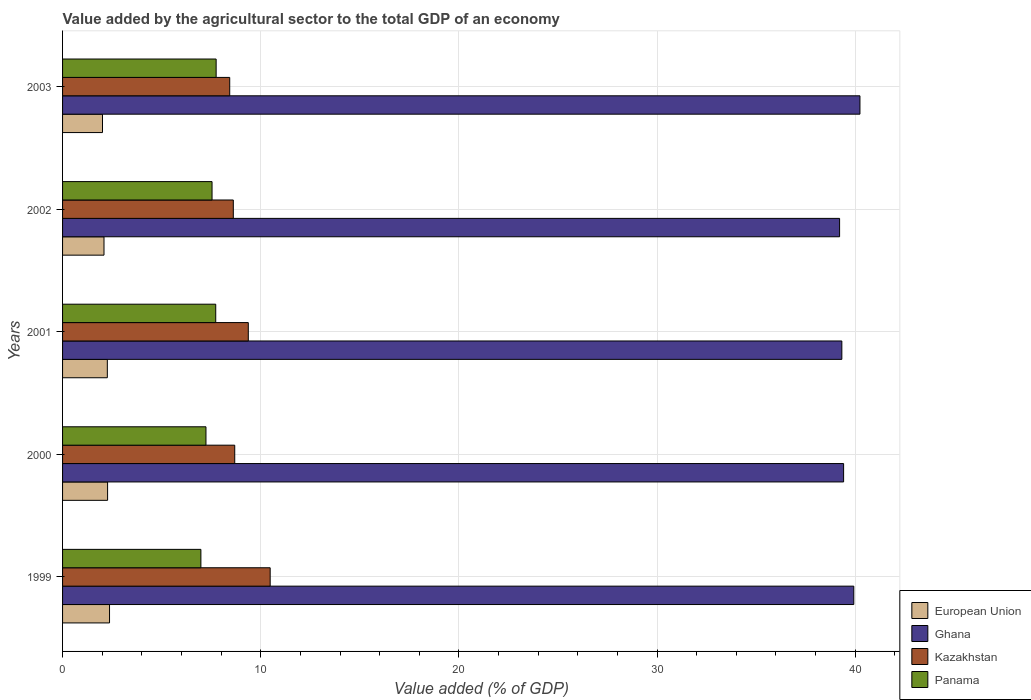How many groups of bars are there?
Ensure brevity in your answer.  5. Are the number of bars on each tick of the Y-axis equal?
Ensure brevity in your answer.  Yes. What is the value added by the agricultural sector to the total GDP in European Union in 2001?
Make the answer very short. 2.26. Across all years, what is the maximum value added by the agricultural sector to the total GDP in Ghana?
Your answer should be compact. 40.24. Across all years, what is the minimum value added by the agricultural sector to the total GDP in European Union?
Your answer should be very brief. 2.02. What is the total value added by the agricultural sector to the total GDP in European Union in the graph?
Provide a short and direct response. 11.01. What is the difference between the value added by the agricultural sector to the total GDP in Kazakhstan in 1999 and that in 2000?
Provide a short and direct response. 1.79. What is the difference between the value added by the agricultural sector to the total GDP in Panama in 2000 and the value added by the agricultural sector to the total GDP in Kazakhstan in 2003?
Keep it short and to the point. -1.2. What is the average value added by the agricultural sector to the total GDP in Panama per year?
Ensure brevity in your answer.  7.45. In the year 2001, what is the difference between the value added by the agricultural sector to the total GDP in Panama and value added by the agricultural sector to the total GDP in European Union?
Your response must be concise. 5.47. In how many years, is the value added by the agricultural sector to the total GDP in Ghana greater than 38 %?
Make the answer very short. 5. What is the ratio of the value added by the agricultural sector to the total GDP in Kazakhstan in 2000 to that in 2002?
Provide a short and direct response. 1.01. Is the value added by the agricultural sector to the total GDP in Ghana in 1999 less than that in 2001?
Offer a very short reply. No. Is the difference between the value added by the agricultural sector to the total GDP in Panama in 2001 and 2002 greater than the difference between the value added by the agricultural sector to the total GDP in European Union in 2001 and 2002?
Provide a short and direct response. Yes. What is the difference between the highest and the second highest value added by the agricultural sector to the total GDP in European Union?
Ensure brevity in your answer.  0.1. What is the difference between the highest and the lowest value added by the agricultural sector to the total GDP in European Union?
Offer a terse response. 0.36. Is the sum of the value added by the agricultural sector to the total GDP in Panama in 1999 and 2002 greater than the maximum value added by the agricultural sector to the total GDP in Ghana across all years?
Make the answer very short. No. What does the 1st bar from the top in 2002 represents?
Provide a short and direct response. Panama. What does the 1st bar from the bottom in 2001 represents?
Ensure brevity in your answer.  European Union. How many bars are there?
Provide a short and direct response. 20. Are all the bars in the graph horizontal?
Offer a terse response. Yes. What is the difference between two consecutive major ticks on the X-axis?
Ensure brevity in your answer.  10. Are the values on the major ticks of X-axis written in scientific E-notation?
Make the answer very short. No. Does the graph contain any zero values?
Provide a succinct answer. No. Does the graph contain grids?
Make the answer very short. Yes. How are the legend labels stacked?
Ensure brevity in your answer.  Vertical. What is the title of the graph?
Offer a terse response. Value added by the agricultural sector to the total GDP of an economy. What is the label or title of the X-axis?
Your answer should be compact. Value added (% of GDP). What is the label or title of the Y-axis?
Provide a succinct answer. Years. What is the Value added (% of GDP) of European Union in 1999?
Offer a terse response. 2.37. What is the Value added (% of GDP) in Ghana in 1999?
Provide a succinct answer. 39.93. What is the Value added (% of GDP) in Kazakhstan in 1999?
Ensure brevity in your answer.  10.48. What is the Value added (% of GDP) of Panama in 1999?
Offer a very short reply. 6.98. What is the Value added (% of GDP) of European Union in 2000?
Offer a terse response. 2.27. What is the Value added (% of GDP) in Ghana in 2000?
Your response must be concise. 39.41. What is the Value added (% of GDP) in Kazakhstan in 2000?
Your answer should be very brief. 8.69. What is the Value added (% of GDP) in Panama in 2000?
Offer a very short reply. 7.24. What is the Value added (% of GDP) in European Union in 2001?
Provide a short and direct response. 2.26. What is the Value added (% of GDP) in Ghana in 2001?
Your answer should be compact. 39.33. What is the Value added (% of GDP) of Kazakhstan in 2001?
Your answer should be compact. 9.37. What is the Value added (% of GDP) in Panama in 2001?
Give a very brief answer. 7.73. What is the Value added (% of GDP) in European Union in 2002?
Your response must be concise. 2.09. What is the Value added (% of GDP) of Ghana in 2002?
Provide a succinct answer. 39.21. What is the Value added (% of GDP) in Kazakhstan in 2002?
Your answer should be compact. 8.62. What is the Value added (% of GDP) of Panama in 2002?
Your answer should be very brief. 7.54. What is the Value added (% of GDP) of European Union in 2003?
Provide a succinct answer. 2.02. What is the Value added (% of GDP) of Ghana in 2003?
Your answer should be compact. 40.24. What is the Value added (% of GDP) of Kazakhstan in 2003?
Make the answer very short. 8.43. What is the Value added (% of GDP) in Panama in 2003?
Your response must be concise. 7.75. Across all years, what is the maximum Value added (% of GDP) in European Union?
Offer a very short reply. 2.37. Across all years, what is the maximum Value added (% of GDP) of Ghana?
Offer a terse response. 40.24. Across all years, what is the maximum Value added (% of GDP) in Kazakhstan?
Your answer should be very brief. 10.48. Across all years, what is the maximum Value added (% of GDP) in Panama?
Make the answer very short. 7.75. Across all years, what is the minimum Value added (% of GDP) of European Union?
Provide a short and direct response. 2.02. Across all years, what is the minimum Value added (% of GDP) in Ghana?
Your answer should be compact. 39.21. Across all years, what is the minimum Value added (% of GDP) in Kazakhstan?
Provide a succinct answer. 8.43. Across all years, what is the minimum Value added (% of GDP) in Panama?
Provide a short and direct response. 6.98. What is the total Value added (% of GDP) in European Union in the graph?
Your answer should be compact. 11.01. What is the total Value added (% of GDP) in Ghana in the graph?
Make the answer very short. 198.12. What is the total Value added (% of GDP) of Kazakhstan in the graph?
Provide a short and direct response. 45.59. What is the total Value added (% of GDP) in Panama in the graph?
Ensure brevity in your answer.  37.24. What is the difference between the Value added (% of GDP) in European Union in 1999 and that in 2000?
Your answer should be very brief. 0.1. What is the difference between the Value added (% of GDP) in Ghana in 1999 and that in 2000?
Give a very brief answer. 0.51. What is the difference between the Value added (% of GDP) in Kazakhstan in 1999 and that in 2000?
Provide a succinct answer. 1.79. What is the difference between the Value added (% of GDP) of Panama in 1999 and that in 2000?
Provide a succinct answer. -0.26. What is the difference between the Value added (% of GDP) of European Union in 1999 and that in 2001?
Your answer should be very brief. 0.11. What is the difference between the Value added (% of GDP) in Ghana in 1999 and that in 2001?
Your answer should be very brief. 0.6. What is the difference between the Value added (% of GDP) of Kazakhstan in 1999 and that in 2001?
Offer a very short reply. 1.1. What is the difference between the Value added (% of GDP) in Panama in 1999 and that in 2001?
Provide a short and direct response. -0.75. What is the difference between the Value added (% of GDP) in European Union in 1999 and that in 2002?
Provide a succinct answer. 0.28. What is the difference between the Value added (% of GDP) of Ghana in 1999 and that in 2002?
Provide a short and direct response. 0.72. What is the difference between the Value added (% of GDP) of Kazakhstan in 1999 and that in 2002?
Your response must be concise. 1.86. What is the difference between the Value added (% of GDP) in Panama in 1999 and that in 2002?
Offer a very short reply. -0.56. What is the difference between the Value added (% of GDP) of European Union in 1999 and that in 2003?
Give a very brief answer. 0.36. What is the difference between the Value added (% of GDP) of Ghana in 1999 and that in 2003?
Keep it short and to the point. -0.31. What is the difference between the Value added (% of GDP) in Kazakhstan in 1999 and that in 2003?
Offer a very short reply. 2.04. What is the difference between the Value added (% of GDP) in Panama in 1999 and that in 2003?
Your answer should be very brief. -0.77. What is the difference between the Value added (% of GDP) of European Union in 2000 and that in 2001?
Offer a terse response. 0.01. What is the difference between the Value added (% of GDP) in Ghana in 2000 and that in 2001?
Offer a very short reply. 0.09. What is the difference between the Value added (% of GDP) of Kazakhstan in 2000 and that in 2001?
Ensure brevity in your answer.  -0.68. What is the difference between the Value added (% of GDP) in Panama in 2000 and that in 2001?
Provide a succinct answer. -0.49. What is the difference between the Value added (% of GDP) in European Union in 2000 and that in 2002?
Make the answer very short. 0.18. What is the difference between the Value added (% of GDP) in Ghana in 2000 and that in 2002?
Provide a succinct answer. 0.2. What is the difference between the Value added (% of GDP) in Kazakhstan in 2000 and that in 2002?
Offer a very short reply. 0.07. What is the difference between the Value added (% of GDP) in Panama in 2000 and that in 2002?
Offer a terse response. -0.31. What is the difference between the Value added (% of GDP) in European Union in 2000 and that in 2003?
Offer a terse response. 0.26. What is the difference between the Value added (% of GDP) in Ghana in 2000 and that in 2003?
Give a very brief answer. -0.82. What is the difference between the Value added (% of GDP) in Kazakhstan in 2000 and that in 2003?
Ensure brevity in your answer.  0.25. What is the difference between the Value added (% of GDP) in Panama in 2000 and that in 2003?
Make the answer very short. -0.51. What is the difference between the Value added (% of GDP) in European Union in 2001 and that in 2002?
Your response must be concise. 0.17. What is the difference between the Value added (% of GDP) of Ghana in 2001 and that in 2002?
Provide a succinct answer. 0.11. What is the difference between the Value added (% of GDP) of Kazakhstan in 2001 and that in 2002?
Your response must be concise. 0.76. What is the difference between the Value added (% of GDP) of Panama in 2001 and that in 2002?
Keep it short and to the point. 0.19. What is the difference between the Value added (% of GDP) of European Union in 2001 and that in 2003?
Provide a succinct answer. 0.24. What is the difference between the Value added (% of GDP) in Ghana in 2001 and that in 2003?
Keep it short and to the point. -0.91. What is the difference between the Value added (% of GDP) of Kazakhstan in 2001 and that in 2003?
Your answer should be compact. 0.94. What is the difference between the Value added (% of GDP) in Panama in 2001 and that in 2003?
Provide a short and direct response. -0.02. What is the difference between the Value added (% of GDP) of European Union in 2002 and that in 2003?
Your answer should be very brief. 0.08. What is the difference between the Value added (% of GDP) in Ghana in 2002 and that in 2003?
Your answer should be compact. -1.03. What is the difference between the Value added (% of GDP) in Kazakhstan in 2002 and that in 2003?
Your response must be concise. 0.18. What is the difference between the Value added (% of GDP) in Panama in 2002 and that in 2003?
Make the answer very short. -0.21. What is the difference between the Value added (% of GDP) in European Union in 1999 and the Value added (% of GDP) in Ghana in 2000?
Offer a terse response. -37.04. What is the difference between the Value added (% of GDP) of European Union in 1999 and the Value added (% of GDP) of Kazakhstan in 2000?
Offer a terse response. -6.32. What is the difference between the Value added (% of GDP) in European Union in 1999 and the Value added (% of GDP) in Panama in 2000?
Offer a terse response. -4.87. What is the difference between the Value added (% of GDP) of Ghana in 1999 and the Value added (% of GDP) of Kazakhstan in 2000?
Make the answer very short. 31.24. What is the difference between the Value added (% of GDP) of Ghana in 1999 and the Value added (% of GDP) of Panama in 2000?
Make the answer very short. 32.69. What is the difference between the Value added (% of GDP) of Kazakhstan in 1999 and the Value added (% of GDP) of Panama in 2000?
Make the answer very short. 3.24. What is the difference between the Value added (% of GDP) of European Union in 1999 and the Value added (% of GDP) of Ghana in 2001?
Make the answer very short. -36.95. What is the difference between the Value added (% of GDP) of European Union in 1999 and the Value added (% of GDP) of Kazakhstan in 2001?
Keep it short and to the point. -7. What is the difference between the Value added (% of GDP) of European Union in 1999 and the Value added (% of GDP) of Panama in 2001?
Make the answer very short. -5.36. What is the difference between the Value added (% of GDP) of Ghana in 1999 and the Value added (% of GDP) of Kazakhstan in 2001?
Provide a short and direct response. 30.56. What is the difference between the Value added (% of GDP) in Ghana in 1999 and the Value added (% of GDP) in Panama in 2001?
Your answer should be very brief. 32.2. What is the difference between the Value added (% of GDP) in Kazakhstan in 1999 and the Value added (% of GDP) in Panama in 2001?
Give a very brief answer. 2.75. What is the difference between the Value added (% of GDP) in European Union in 1999 and the Value added (% of GDP) in Ghana in 2002?
Give a very brief answer. -36.84. What is the difference between the Value added (% of GDP) of European Union in 1999 and the Value added (% of GDP) of Kazakhstan in 2002?
Your response must be concise. -6.25. What is the difference between the Value added (% of GDP) of European Union in 1999 and the Value added (% of GDP) of Panama in 2002?
Keep it short and to the point. -5.17. What is the difference between the Value added (% of GDP) of Ghana in 1999 and the Value added (% of GDP) of Kazakhstan in 2002?
Your response must be concise. 31.31. What is the difference between the Value added (% of GDP) in Ghana in 1999 and the Value added (% of GDP) in Panama in 2002?
Keep it short and to the point. 32.38. What is the difference between the Value added (% of GDP) in Kazakhstan in 1999 and the Value added (% of GDP) in Panama in 2002?
Your response must be concise. 2.93. What is the difference between the Value added (% of GDP) of European Union in 1999 and the Value added (% of GDP) of Ghana in 2003?
Offer a terse response. -37.87. What is the difference between the Value added (% of GDP) in European Union in 1999 and the Value added (% of GDP) in Kazakhstan in 2003?
Offer a very short reply. -6.06. What is the difference between the Value added (% of GDP) of European Union in 1999 and the Value added (% of GDP) of Panama in 2003?
Your answer should be compact. -5.38. What is the difference between the Value added (% of GDP) of Ghana in 1999 and the Value added (% of GDP) of Kazakhstan in 2003?
Give a very brief answer. 31.49. What is the difference between the Value added (% of GDP) in Ghana in 1999 and the Value added (% of GDP) in Panama in 2003?
Your answer should be very brief. 32.18. What is the difference between the Value added (% of GDP) of Kazakhstan in 1999 and the Value added (% of GDP) of Panama in 2003?
Provide a short and direct response. 2.73. What is the difference between the Value added (% of GDP) in European Union in 2000 and the Value added (% of GDP) in Ghana in 2001?
Your answer should be very brief. -37.05. What is the difference between the Value added (% of GDP) of European Union in 2000 and the Value added (% of GDP) of Kazakhstan in 2001?
Ensure brevity in your answer.  -7.1. What is the difference between the Value added (% of GDP) in European Union in 2000 and the Value added (% of GDP) in Panama in 2001?
Your response must be concise. -5.46. What is the difference between the Value added (% of GDP) of Ghana in 2000 and the Value added (% of GDP) of Kazakhstan in 2001?
Your answer should be very brief. 30.04. What is the difference between the Value added (% of GDP) in Ghana in 2000 and the Value added (% of GDP) in Panama in 2001?
Provide a short and direct response. 31.68. What is the difference between the Value added (% of GDP) in Kazakhstan in 2000 and the Value added (% of GDP) in Panama in 2001?
Provide a short and direct response. 0.96. What is the difference between the Value added (% of GDP) in European Union in 2000 and the Value added (% of GDP) in Ghana in 2002?
Your answer should be very brief. -36.94. What is the difference between the Value added (% of GDP) of European Union in 2000 and the Value added (% of GDP) of Kazakhstan in 2002?
Provide a succinct answer. -6.34. What is the difference between the Value added (% of GDP) in European Union in 2000 and the Value added (% of GDP) in Panama in 2002?
Your answer should be compact. -5.27. What is the difference between the Value added (% of GDP) of Ghana in 2000 and the Value added (% of GDP) of Kazakhstan in 2002?
Your answer should be compact. 30.8. What is the difference between the Value added (% of GDP) of Ghana in 2000 and the Value added (% of GDP) of Panama in 2002?
Make the answer very short. 31.87. What is the difference between the Value added (% of GDP) in Kazakhstan in 2000 and the Value added (% of GDP) in Panama in 2002?
Your response must be concise. 1.14. What is the difference between the Value added (% of GDP) of European Union in 2000 and the Value added (% of GDP) of Ghana in 2003?
Make the answer very short. -37.97. What is the difference between the Value added (% of GDP) of European Union in 2000 and the Value added (% of GDP) of Kazakhstan in 2003?
Your answer should be compact. -6.16. What is the difference between the Value added (% of GDP) of European Union in 2000 and the Value added (% of GDP) of Panama in 2003?
Keep it short and to the point. -5.48. What is the difference between the Value added (% of GDP) in Ghana in 2000 and the Value added (% of GDP) in Kazakhstan in 2003?
Your answer should be very brief. 30.98. What is the difference between the Value added (% of GDP) in Ghana in 2000 and the Value added (% of GDP) in Panama in 2003?
Keep it short and to the point. 31.66. What is the difference between the Value added (% of GDP) in Kazakhstan in 2000 and the Value added (% of GDP) in Panama in 2003?
Ensure brevity in your answer.  0.94. What is the difference between the Value added (% of GDP) in European Union in 2001 and the Value added (% of GDP) in Ghana in 2002?
Provide a succinct answer. -36.95. What is the difference between the Value added (% of GDP) of European Union in 2001 and the Value added (% of GDP) of Kazakhstan in 2002?
Your answer should be very brief. -6.36. What is the difference between the Value added (% of GDP) in European Union in 2001 and the Value added (% of GDP) in Panama in 2002?
Your response must be concise. -5.28. What is the difference between the Value added (% of GDP) of Ghana in 2001 and the Value added (% of GDP) of Kazakhstan in 2002?
Your answer should be very brief. 30.71. What is the difference between the Value added (% of GDP) of Ghana in 2001 and the Value added (% of GDP) of Panama in 2002?
Ensure brevity in your answer.  31.78. What is the difference between the Value added (% of GDP) in Kazakhstan in 2001 and the Value added (% of GDP) in Panama in 2002?
Ensure brevity in your answer.  1.83. What is the difference between the Value added (% of GDP) in European Union in 2001 and the Value added (% of GDP) in Ghana in 2003?
Your response must be concise. -37.98. What is the difference between the Value added (% of GDP) in European Union in 2001 and the Value added (% of GDP) in Kazakhstan in 2003?
Your response must be concise. -6.18. What is the difference between the Value added (% of GDP) in European Union in 2001 and the Value added (% of GDP) in Panama in 2003?
Keep it short and to the point. -5.49. What is the difference between the Value added (% of GDP) in Ghana in 2001 and the Value added (% of GDP) in Kazakhstan in 2003?
Ensure brevity in your answer.  30.89. What is the difference between the Value added (% of GDP) of Ghana in 2001 and the Value added (% of GDP) of Panama in 2003?
Make the answer very short. 31.57. What is the difference between the Value added (% of GDP) of Kazakhstan in 2001 and the Value added (% of GDP) of Panama in 2003?
Offer a terse response. 1.62. What is the difference between the Value added (% of GDP) in European Union in 2002 and the Value added (% of GDP) in Ghana in 2003?
Provide a short and direct response. -38.15. What is the difference between the Value added (% of GDP) in European Union in 2002 and the Value added (% of GDP) in Kazakhstan in 2003?
Give a very brief answer. -6.34. What is the difference between the Value added (% of GDP) in European Union in 2002 and the Value added (% of GDP) in Panama in 2003?
Offer a terse response. -5.66. What is the difference between the Value added (% of GDP) in Ghana in 2002 and the Value added (% of GDP) in Kazakhstan in 2003?
Offer a very short reply. 30.78. What is the difference between the Value added (% of GDP) in Ghana in 2002 and the Value added (% of GDP) in Panama in 2003?
Ensure brevity in your answer.  31.46. What is the difference between the Value added (% of GDP) of Kazakhstan in 2002 and the Value added (% of GDP) of Panama in 2003?
Provide a succinct answer. 0.87. What is the average Value added (% of GDP) of European Union per year?
Provide a short and direct response. 2.2. What is the average Value added (% of GDP) of Ghana per year?
Keep it short and to the point. 39.62. What is the average Value added (% of GDP) in Kazakhstan per year?
Offer a terse response. 9.12. What is the average Value added (% of GDP) in Panama per year?
Give a very brief answer. 7.45. In the year 1999, what is the difference between the Value added (% of GDP) in European Union and Value added (% of GDP) in Ghana?
Offer a very short reply. -37.56. In the year 1999, what is the difference between the Value added (% of GDP) of European Union and Value added (% of GDP) of Kazakhstan?
Provide a short and direct response. -8.11. In the year 1999, what is the difference between the Value added (% of GDP) of European Union and Value added (% of GDP) of Panama?
Provide a short and direct response. -4.61. In the year 1999, what is the difference between the Value added (% of GDP) in Ghana and Value added (% of GDP) in Kazakhstan?
Offer a terse response. 29.45. In the year 1999, what is the difference between the Value added (% of GDP) of Ghana and Value added (% of GDP) of Panama?
Offer a terse response. 32.95. In the year 1999, what is the difference between the Value added (% of GDP) in Kazakhstan and Value added (% of GDP) in Panama?
Keep it short and to the point. 3.5. In the year 2000, what is the difference between the Value added (% of GDP) in European Union and Value added (% of GDP) in Ghana?
Offer a terse response. -37.14. In the year 2000, what is the difference between the Value added (% of GDP) of European Union and Value added (% of GDP) of Kazakhstan?
Give a very brief answer. -6.42. In the year 2000, what is the difference between the Value added (% of GDP) in European Union and Value added (% of GDP) in Panama?
Keep it short and to the point. -4.96. In the year 2000, what is the difference between the Value added (% of GDP) of Ghana and Value added (% of GDP) of Kazakhstan?
Ensure brevity in your answer.  30.73. In the year 2000, what is the difference between the Value added (% of GDP) in Ghana and Value added (% of GDP) in Panama?
Make the answer very short. 32.18. In the year 2000, what is the difference between the Value added (% of GDP) in Kazakhstan and Value added (% of GDP) in Panama?
Your answer should be very brief. 1.45. In the year 2001, what is the difference between the Value added (% of GDP) of European Union and Value added (% of GDP) of Ghana?
Your response must be concise. -37.07. In the year 2001, what is the difference between the Value added (% of GDP) in European Union and Value added (% of GDP) in Kazakhstan?
Your answer should be very brief. -7.11. In the year 2001, what is the difference between the Value added (% of GDP) of European Union and Value added (% of GDP) of Panama?
Provide a short and direct response. -5.47. In the year 2001, what is the difference between the Value added (% of GDP) in Ghana and Value added (% of GDP) in Kazakhstan?
Offer a terse response. 29.95. In the year 2001, what is the difference between the Value added (% of GDP) of Ghana and Value added (% of GDP) of Panama?
Provide a short and direct response. 31.6. In the year 2001, what is the difference between the Value added (% of GDP) in Kazakhstan and Value added (% of GDP) in Panama?
Make the answer very short. 1.64. In the year 2002, what is the difference between the Value added (% of GDP) in European Union and Value added (% of GDP) in Ghana?
Give a very brief answer. -37.12. In the year 2002, what is the difference between the Value added (% of GDP) in European Union and Value added (% of GDP) in Kazakhstan?
Provide a short and direct response. -6.53. In the year 2002, what is the difference between the Value added (% of GDP) of European Union and Value added (% of GDP) of Panama?
Provide a succinct answer. -5.45. In the year 2002, what is the difference between the Value added (% of GDP) of Ghana and Value added (% of GDP) of Kazakhstan?
Make the answer very short. 30.6. In the year 2002, what is the difference between the Value added (% of GDP) of Ghana and Value added (% of GDP) of Panama?
Keep it short and to the point. 31.67. In the year 2002, what is the difference between the Value added (% of GDP) of Kazakhstan and Value added (% of GDP) of Panama?
Provide a succinct answer. 1.07. In the year 2003, what is the difference between the Value added (% of GDP) of European Union and Value added (% of GDP) of Ghana?
Make the answer very short. -38.22. In the year 2003, what is the difference between the Value added (% of GDP) in European Union and Value added (% of GDP) in Kazakhstan?
Offer a terse response. -6.42. In the year 2003, what is the difference between the Value added (% of GDP) in European Union and Value added (% of GDP) in Panama?
Provide a succinct answer. -5.74. In the year 2003, what is the difference between the Value added (% of GDP) in Ghana and Value added (% of GDP) in Kazakhstan?
Offer a very short reply. 31.8. In the year 2003, what is the difference between the Value added (% of GDP) of Ghana and Value added (% of GDP) of Panama?
Make the answer very short. 32.49. In the year 2003, what is the difference between the Value added (% of GDP) of Kazakhstan and Value added (% of GDP) of Panama?
Your answer should be very brief. 0.68. What is the ratio of the Value added (% of GDP) of European Union in 1999 to that in 2000?
Ensure brevity in your answer.  1.04. What is the ratio of the Value added (% of GDP) in Kazakhstan in 1999 to that in 2000?
Make the answer very short. 1.21. What is the ratio of the Value added (% of GDP) in Panama in 1999 to that in 2000?
Offer a very short reply. 0.96. What is the ratio of the Value added (% of GDP) of European Union in 1999 to that in 2001?
Ensure brevity in your answer.  1.05. What is the ratio of the Value added (% of GDP) of Ghana in 1999 to that in 2001?
Provide a succinct answer. 1.02. What is the ratio of the Value added (% of GDP) in Kazakhstan in 1999 to that in 2001?
Your answer should be compact. 1.12. What is the ratio of the Value added (% of GDP) in Panama in 1999 to that in 2001?
Provide a succinct answer. 0.9. What is the ratio of the Value added (% of GDP) of European Union in 1999 to that in 2002?
Your answer should be very brief. 1.13. What is the ratio of the Value added (% of GDP) in Ghana in 1999 to that in 2002?
Ensure brevity in your answer.  1.02. What is the ratio of the Value added (% of GDP) in Kazakhstan in 1999 to that in 2002?
Provide a succinct answer. 1.22. What is the ratio of the Value added (% of GDP) of Panama in 1999 to that in 2002?
Keep it short and to the point. 0.93. What is the ratio of the Value added (% of GDP) of European Union in 1999 to that in 2003?
Offer a terse response. 1.18. What is the ratio of the Value added (% of GDP) in Kazakhstan in 1999 to that in 2003?
Keep it short and to the point. 1.24. What is the ratio of the Value added (% of GDP) in Panama in 1999 to that in 2003?
Ensure brevity in your answer.  0.9. What is the ratio of the Value added (% of GDP) in European Union in 2000 to that in 2001?
Give a very brief answer. 1.01. What is the ratio of the Value added (% of GDP) in Kazakhstan in 2000 to that in 2001?
Keep it short and to the point. 0.93. What is the ratio of the Value added (% of GDP) of Panama in 2000 to that in 2001?
Provide a short and direct response. 0.94. What is the ratio of the Value added (% of GDP) of European Union in 2000 to that in 2002?
Make the answer very short. 1.09. What is the ratio of the Value added (% of GDP) of Kazakhstan in 2000 to that in 2002?
Offer a terse response. 1.01. What is the ratio of the Value added (% of GDP) in Panama in 2000 to that in 2002?
Provide a succinct answer. 0.96. What is the ratio of the Value added (% of GDP) of European Union in 2000 to that in 2003?
Your answer should be very brief. 1.13. What is the ratio of the Value added (% of GDP) of Ghana in 2000 to that in 2003?
Keep it short and to the point. 0.98. What is the ratio of the Value added (% of GDP) in Kazakhstan in 2000 to that in 2003?
Keep it short and to the point. 1.03. What is the ratio of the Value added (% of GDP) of Panama in 2000 to that in 2003?
Make the answer very short. 0.93. What is the ratio of the Value added (% of GDP) in European Union in 2001 to that in 2002?
Keep it short and to the point. 1.08. What is the ratio of the Value added (% of GDP) in Ghana in 2001 to that in 2002?
Offer a terse response. 1. What is the ratio of the Value added (% of GDP) in Kazakhstan in 2001 to that in 2002?
Keep it short and to the point. 1.09. What is the ratio of the Value added (% of GDP) in Panama in 2001 to that in 2002?
Provide a succinct answer. 1.02. What is the ratio of the Value added (% of GDP) in European Union in 2001 to that in 2003?
Provide a short and direct response. 1.12. What is the ratio of the Value added (% of GDP) in Ghana in 2001 to that in 2003?
Give a very brief answer. 0.98. What is the ratio of the Value added (% of GDP) of Kazakhstan in 2001 to that in 2003?
Ensure brevity in your answer.  1.11. What is the ratio of the Value added (% of GDP) in European Union in 2002 to that in 2003?
Provide a succinct answer. 1.04. What is the ratio of the Value added (% of GDP) in Ghana in 2002 to that in 2003?
Provide a succinct answer. 0.97. What is the ratio of the Value added (% of GDP) of Kazakhstan in 2002 to that in 2003?
Give a very brief answer. 1.02. What is the ratio of the Value added (% of GDP) in Panama in 2002 to that in 2003?
Keep it short and to the point. 0.97. What is the difference between the highest and the second highest Value added (% of GDP) of European Union?
Provide a succinct answer. 0.1. What is the difference between the highest and the second highest Value added (% of GDP) in Ghana?
Make the answer very short. 0.31. What is the difference between the highest and the second highest Value added (% of GDP) in Kazakhstan?
Your response must be concise. 1.1. What is the difference between the highest and the second highest Value added (% of GDP) of Panama?
Ensure brevity in your answer.  0.02. What is the difference between the highest and the lowest Value added (% of GDP) in European Union?
Your response must be concise. 0.36. What is the difference between the highest and the lowest Value added (% of GDP) of Ghana?
Keep it short and to the point. 1.03. What is the difference between the highest and the lowest Value added (% of GDP) in Kazakhstan?
Your answer should be compact. 2.04. What is the difference between the highest and the lowest Value added (% of GDP) in Panama?
Make the answer very short. 0.77. 